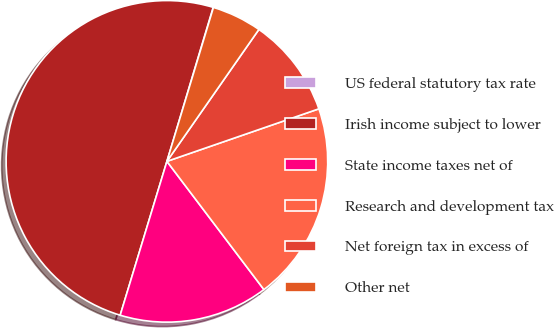<chart> <loc_0><loc_0><loc_500><loc_500><pie_chart><fcel>US federal statutory tax rate<fcel>Irish income subject to lower<fcel>State income taxes net of<fcel>Research and development tax<fcel>Net foreign tax in excess of<fcel>Other net<nl><fcel>0.03%<fcel>49.95%<fcel>15.0%<fcel>19.99%<fcel>10.01%<fcel>5.02%<nl></chart> 